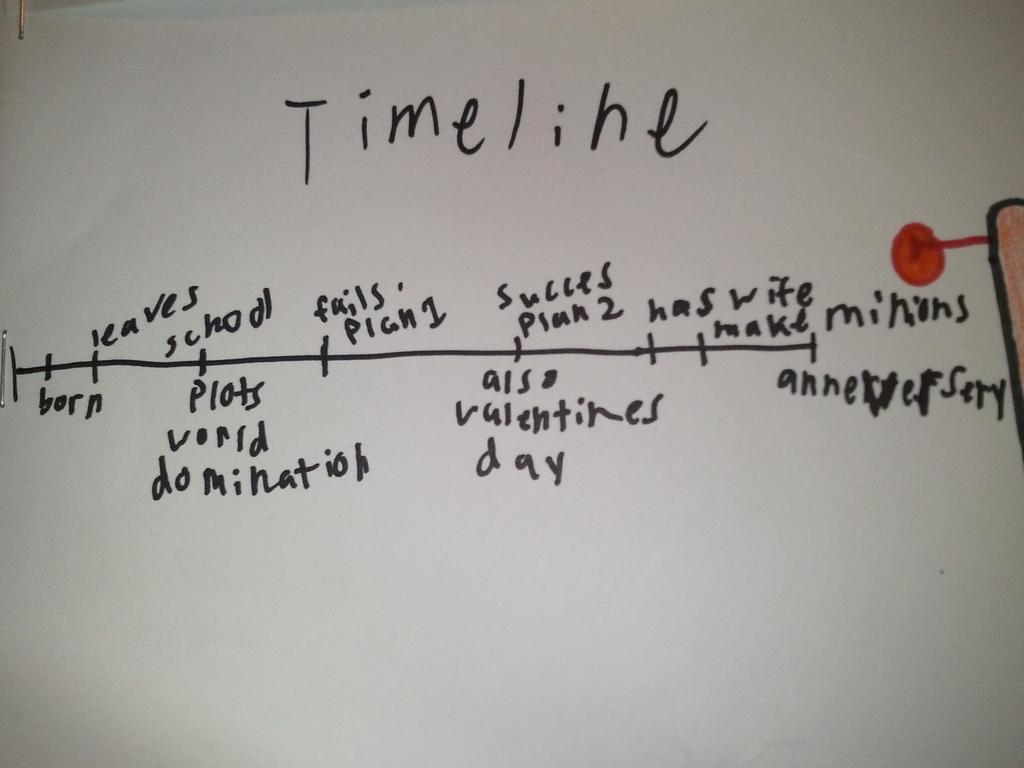<image>
Give a short and clear explanation of the subsequent image. a white board with a timeline drawn on it. 